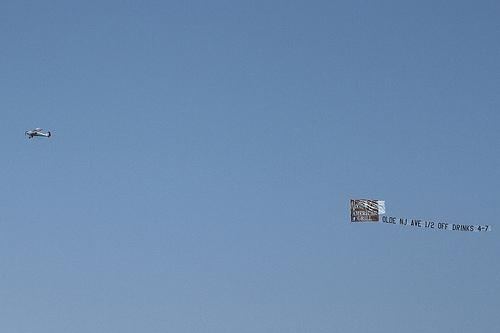Question: where is the kite?
Choices:
A. In the childs hands.
B. Crashed on the beach.
C. In between the red kite and the striped kite.
D. In the sky.
Answer with the letter. Answer: D Question: who is flying the kite?
Choices:
A. The man.
B. The little girl.
C. A person.
D. The teenage boy.
Answer with the letter. Answer: C Question: what color is the sky?
Choices:
A. White.
B. Gray.
C. White and blue.
D. Blue.
Answer with the letter. Answer: D Question: when is it?
Choices:
A. Day time.
B. Night time.
C. Just before dusk.
D. Just before daylight.
Answer with the letter. Answer: A Question: what is the plane doing?
Choices:
A. Boarding people.
B. Unboarding people.
C. Taking off.
D. Flying.
Answer with the letter. Answer: D 